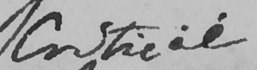Please provide the text content of this handwritten line. Critical 